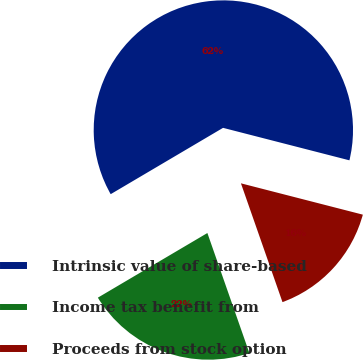Convert chart to OTSL. <chart><loc_0><loc_0><loc_500><loc_500><pie_chart><fcel>Intrinsic value of share-based<fcel>Income tax benefit from<fcel>Proceeds from stock option<nl><fcel>62.49%<fcel>21.87%<fcel>15.64%<nl></chart> 